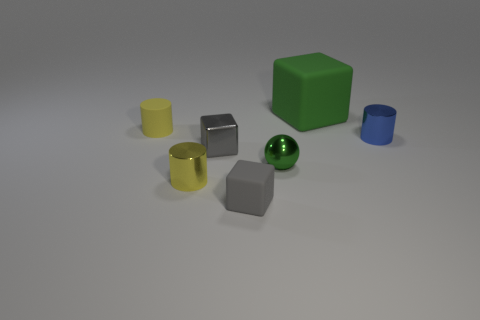Subtract all green cubes. How many cubes are left? 2 Add 3 large green cubes. How many objects exist? 10 Subtract all blue cylinders. How many cylinders are left? 2 Subtract all balls. How many objects are left? 6 Add 1 green shiny objects. How many green shiny objects are left? 2 Add 4 big brown objects. How many big brown objects exist? 4 Subtract 0 brown cylinders. How many objects are left? 7 Subtract 1 blocks. How many blocks are left? 2 Subtract all blue balls. Subtract all yellow cubes. How many balls are left? 1 Subtract all cyan spheres. How many green blocks are left? 1 